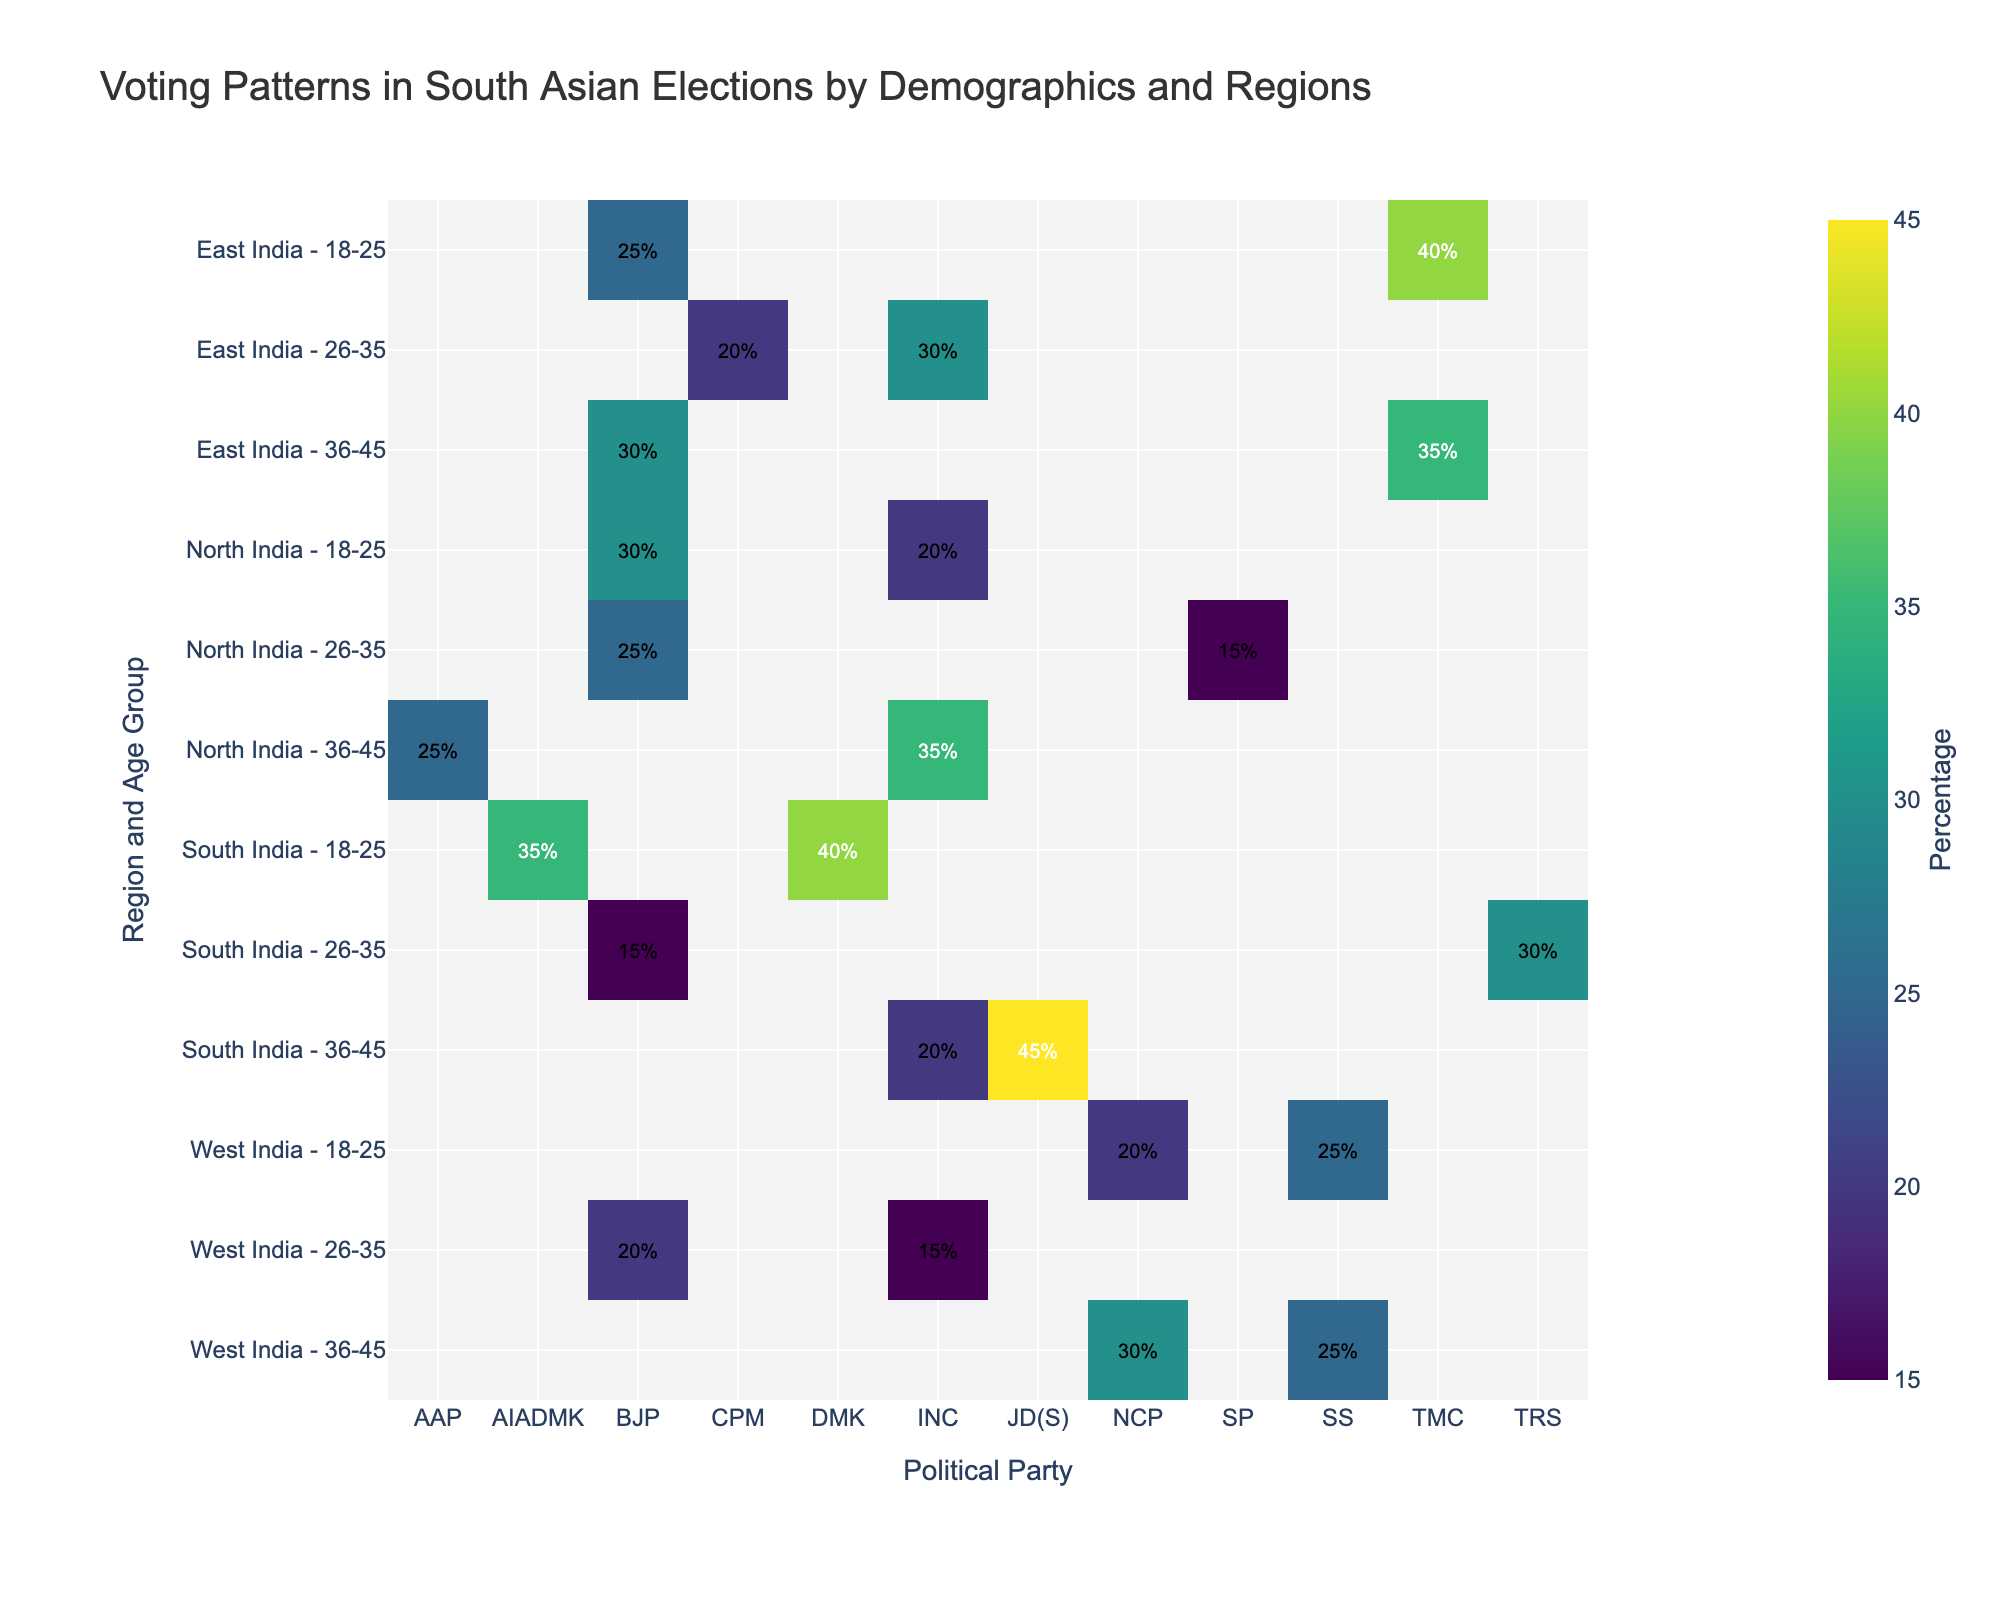What is the title of the heatmap? The title of the heatmap is written at the top, identifying the subject of the visualization.
Answer: Voting Patterns in South Asian Elections by Demographics and Regions Which region and age group has the highest percentage of votes for BJP in North India? The North India region and age group combinations are displayed on the y-axis. You can identify the highest percentage for BJP by examining the color intensity or number in the cell.
Answer: North India - 36-45 What is the average percentage of votes for INC in South India across all age groups? To find the average, note all the relevant percentages for INC in South India: 18-25 (none), 26-35 (none), 36-45 (20%). Sum these values (20) and divide by the number of relevant cells (1).
Answer: 20% Which political party has the least support in East India - 26-35 age group? Locate the East India - 26-35 row and compare the percentages across political parties. The smallest value indicates the least support.
Answer: CPM How does the percentage of votes for TMC in East India - 18-25 compare to West India - 36-45 age groups? First, identify the percentages for TMC in East India - 18-25 and then in West India - 36-45. Compare the two values to determine whether one is greater than the other.
Answer: TMC has 40% in East India - 18-25 and 0% in West India - 36-45, thus it is higher in East India - 18-25 What is the sum of BJP votes across all regions for the 18-25 age group? Identify the BJP percentages within the 18-25 age group for each region: North India (30%), South India (none), East India (25%), West India (none). Sum these values: 30 + 25.
Answer: 55% Which gender shows higher voting percentages for SS in West India? Compare the SS percentages in West India among gender and age groups: male group 18-25 (25%), female group 36-45 (none). Thus, males exhibit a higher voting percentage.
Answer: Male Identify the age group with the highest support for JD(S) in South India. Navigate through the South India rows, identifying JD(S) percentages among the various age groups. The highest percentage indicates the targeted age group.
Answer: 36-45 Is there a noticeable difference in voting patterns for BJP between North India and South India regions for the age group 26-35? Compare the BJP percentages for the 26-35 age group in North India (15%) and South India (15%). There is no noticeable difference.
Answer: No difference How does AAP's popularity in North India - 36-45 age group compare to JD(S) in South India - 36-45? Examine the heatmap for percentages of AAP in North India - 36-45 (25%) and JD(S) in South India - 36-45 (45%). Compare the two values directly.
Answer: JD(S) in South India - 36-45 is more popular at 45% 